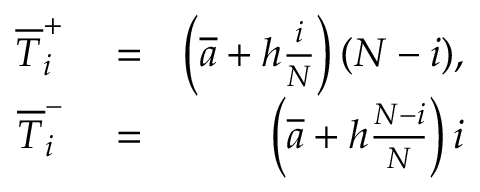<formula> <loc_0><loc_0><loc_500><loc_500>\begin{array} { r l r } { \overline { T } _ { i } ^ { + } } & = } & { \left ( \overline { a } + h \frac { i } { N } \right ) ( N - i ) , } \\ { \overline { T } _ { i } ^ { - } } & = } & { \left ( \overline { a } + h \frac { N - i } { N } \right ) i } \end{array}</formula> 